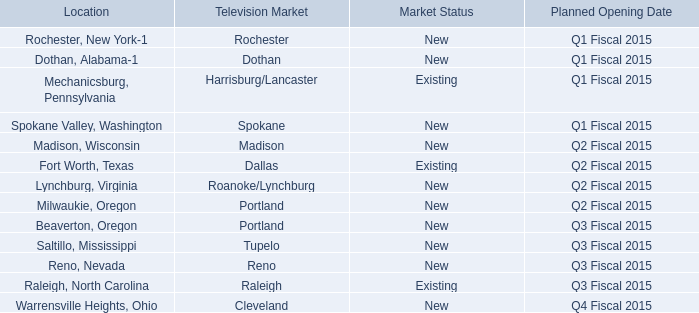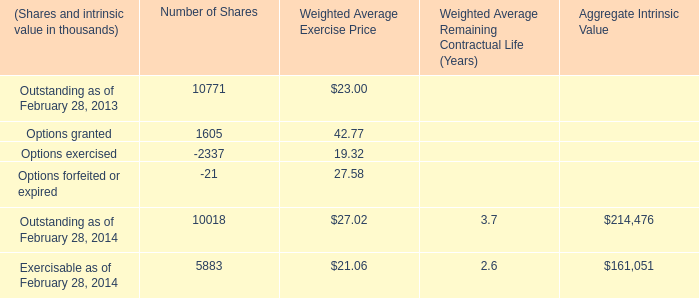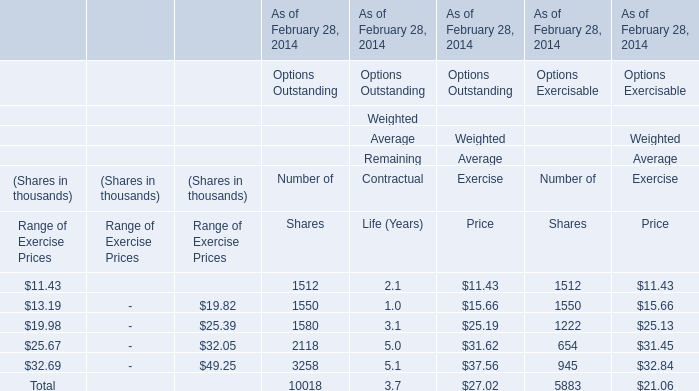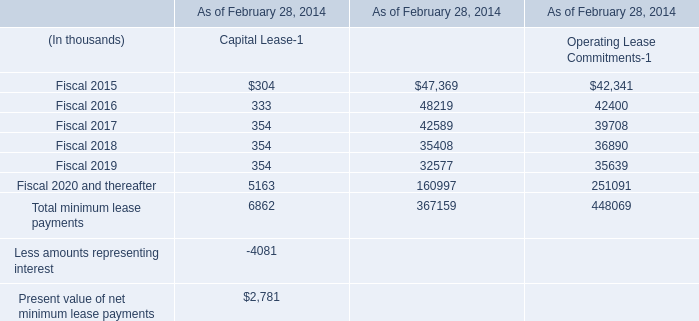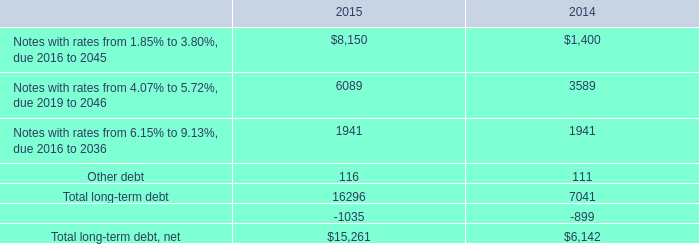What is the Number of Shares of the Range of Exercise Prices: $13.19-$19.82 in terms of Options Outstanding As of February 28, 2014? (in thousand) 
Answer: 1550. 